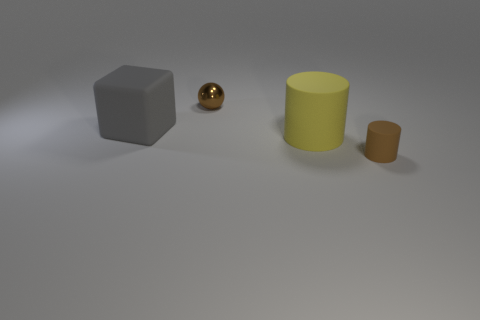What size is the brown cylinder that is made of the same material as the gray cube?
Provide a succinct answer. Small. The tiny thing on the right side of the large matte object that is to the right of the tiny brown metallic thing is what color?
Keep it short and to the point. Brown. How many gray objects are made of the same material as the cube?
Your answer should be very brief. 0. What number of matte things are cubes or spheres?
Your response must be concise. 1. There is a cylinder that is the same size as the sphere; what is its material?
Give a very brief answer. Rubber. Is there a small purple thing made of the same material as the brown cylinder?
Keep it short and to the point. No. What shape is the matte object that is left of the tiny metallic ball to the right of the large rubber object that is behind the big yellow thing?
Provide a succinct answer. Cube. Do the metal ball and the brown thing in front of the big yellow matte thing have the same size?
Keep it short and to the point. Yes. What is the shape of the thing that is both in front of the tiny metallic ball and to the left of the yellow rubber cylinder?
Your response must be concise. Cube. What number of small things are either brown cylinders or spheres?
Keep it short and to the point. 2. 